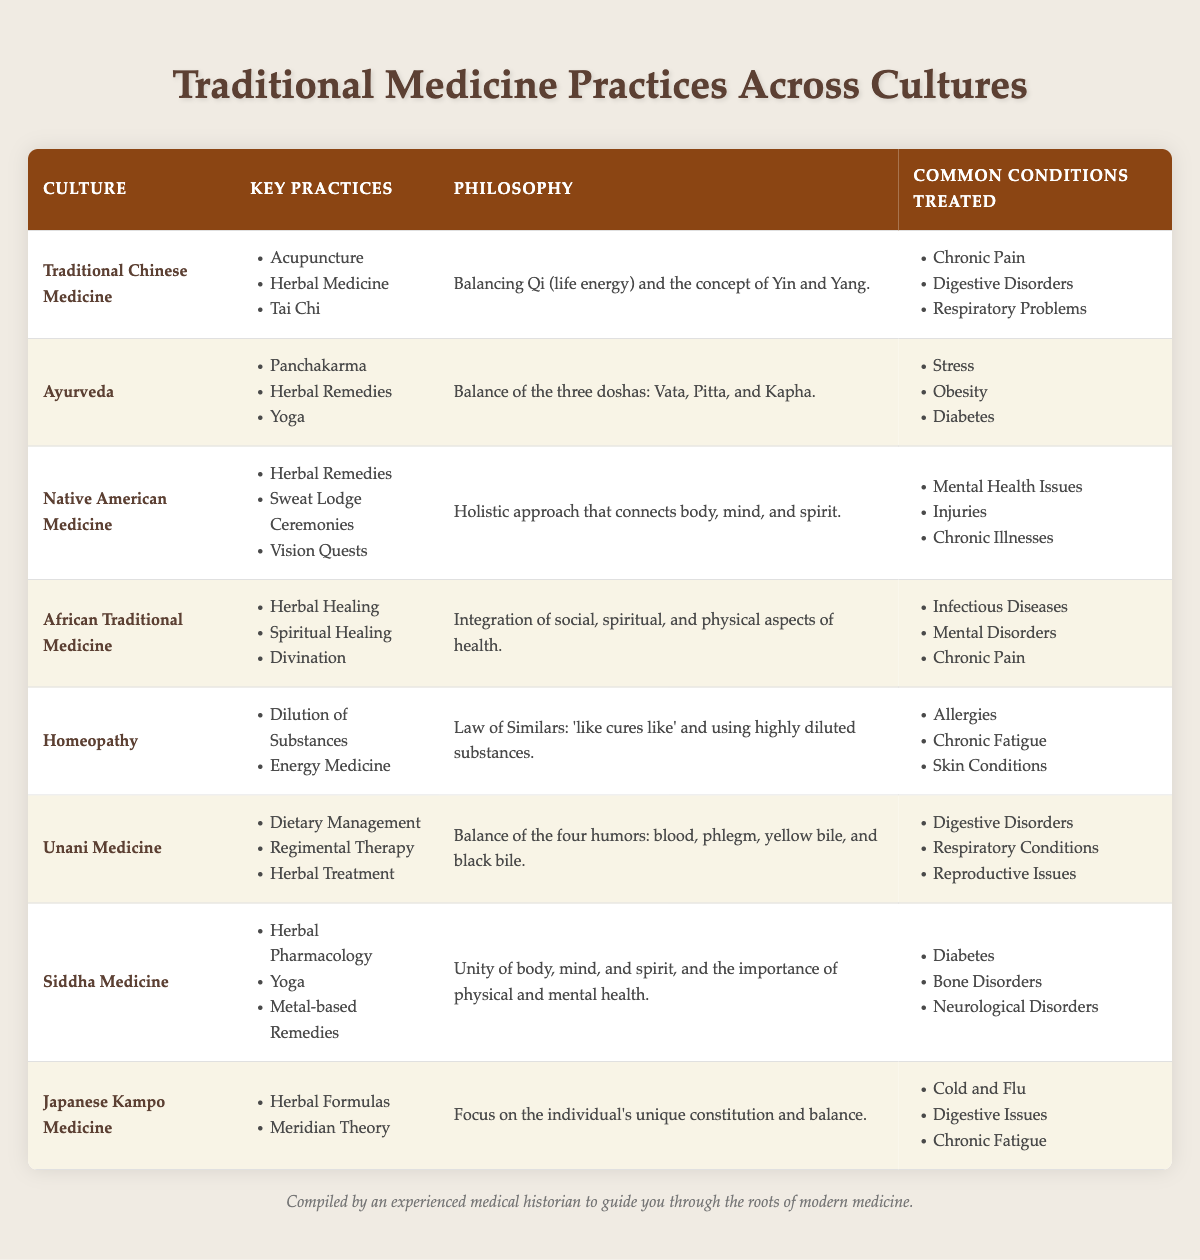What are the key practices of Ayurveda? According to the table, the key practices of Ayurveda are listed as Panchakarma, Herbal Remedies, and Yoga. These practices are mentioned directly in the "Key Practices" column for Ayurveda.
Answer: Panchakarma, Herbal Remedies, Yoga Which culture focuses on balancing Qi and Yin and Yang? The table indicates that Traditional Chinese Medicine emphasizes the concept of balancing Qi (life energy) and the duality of Yin and Yang. This philosophy is specifically outlined in the "Philosophy" column for this culture.
Answer: Traditional Chinese Medicine Does Native American Medicine use Vision Quests as a practice? Yes, the table confirms that Vision Quests are listed as one of the key practices of Native American Medicine, as seen in the corresponding row under "Key Practices."
Answer: Yes Which cultures treat Chronic Pain as a common condition? The table shows that both Traditional Chinese Medicine and African Traditional Medicine list Chronic Pain as a common condition treated. This includes checking both "Common Conditions Treated" columns for these two cultures.
Answer: Traditional Chinese Medicine; African Traditional Medicine What is the average number of key practices across the cultures listed? There are 8 cultures listed, and each culture has the following number of key practices: 3, 3, 3, 3, 2, 3, 3, 2 (totaling 21 practices). To find the average, divide the total number of key practices (21) by the number of cultures (8), which equals 2.625.
Answer: 2.625 Which traditional medicine practice incorporates dietary management? The table shows that Unani Medicine includes dietary management as one of its key practices. This information can be found by referencing the "Key Practices" column for Unani Medicine.
Answer: Unani Medicine Do all cultures listed treat Digestive Disorders? No, while Ayurveda, Unani Medicine, Traditional Chinese Medicine, and Japanese Kampo Medicine treat Digestive Disorders, Not all cultures listed have this condition in their treatment scope. This is confirmed by checking the "Common Conditions Treated" column for each culture.
Answer: No Which culture combines spiritual healing within its traditional practices? According to the table, African Traditional Medicine includes spiritual healing among its key practices. This information is directly stated in the "Key Practices" column.
Answer: African Traditional Medicine 